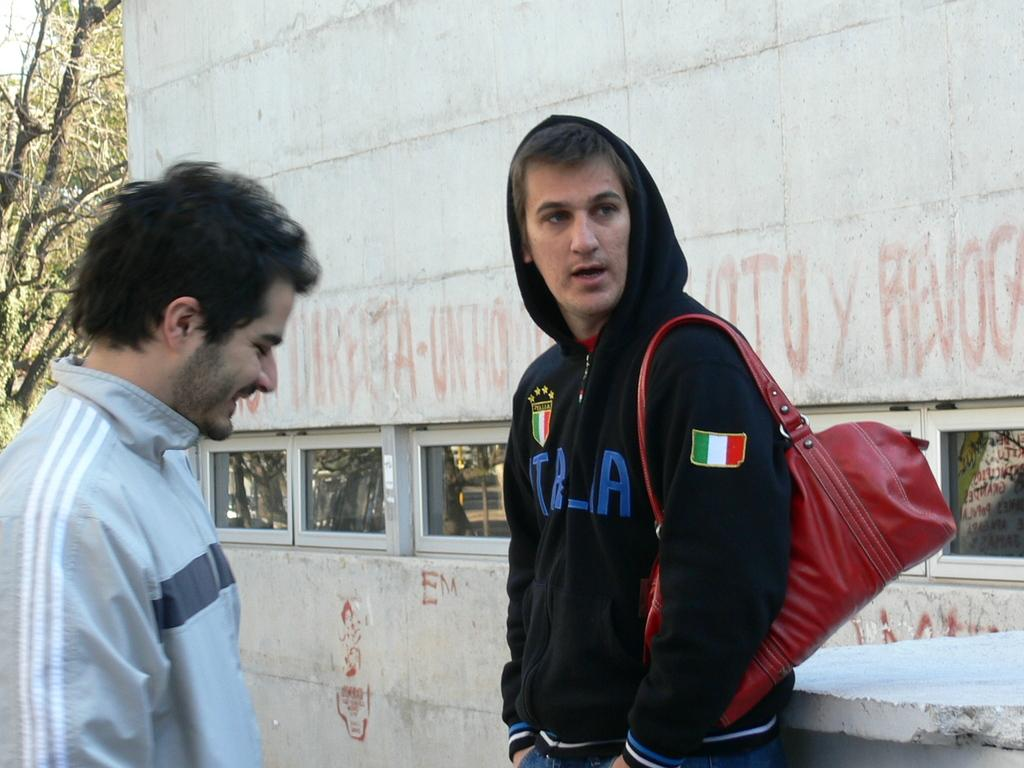<image>
Summarize the visual content of the image. A man in a black sweatshirt with the word italia written on it. 